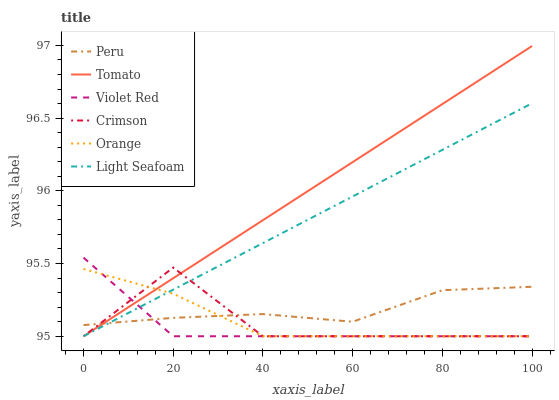Does Orange have the minimum area under the curve?
Answer yes or no. No. Does Orange have the maximum area under the curve?
Answer yes or no. No. Is Violet Red the smoothest?
Answer yes or no. No. Is Violet Red the roughest?
Answer yes or no. No. Does Peru have the lowest value?
Answer yes or no. No. Does Violet Red have the highest value?
Answer yes or no. No. 